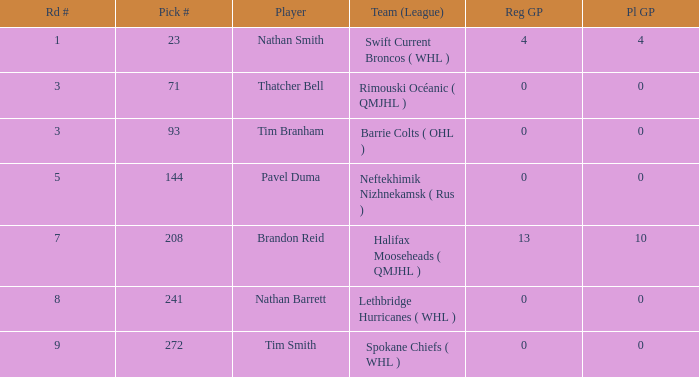How many reg GP for nathan barrett in a round less than 8? 0.0. 